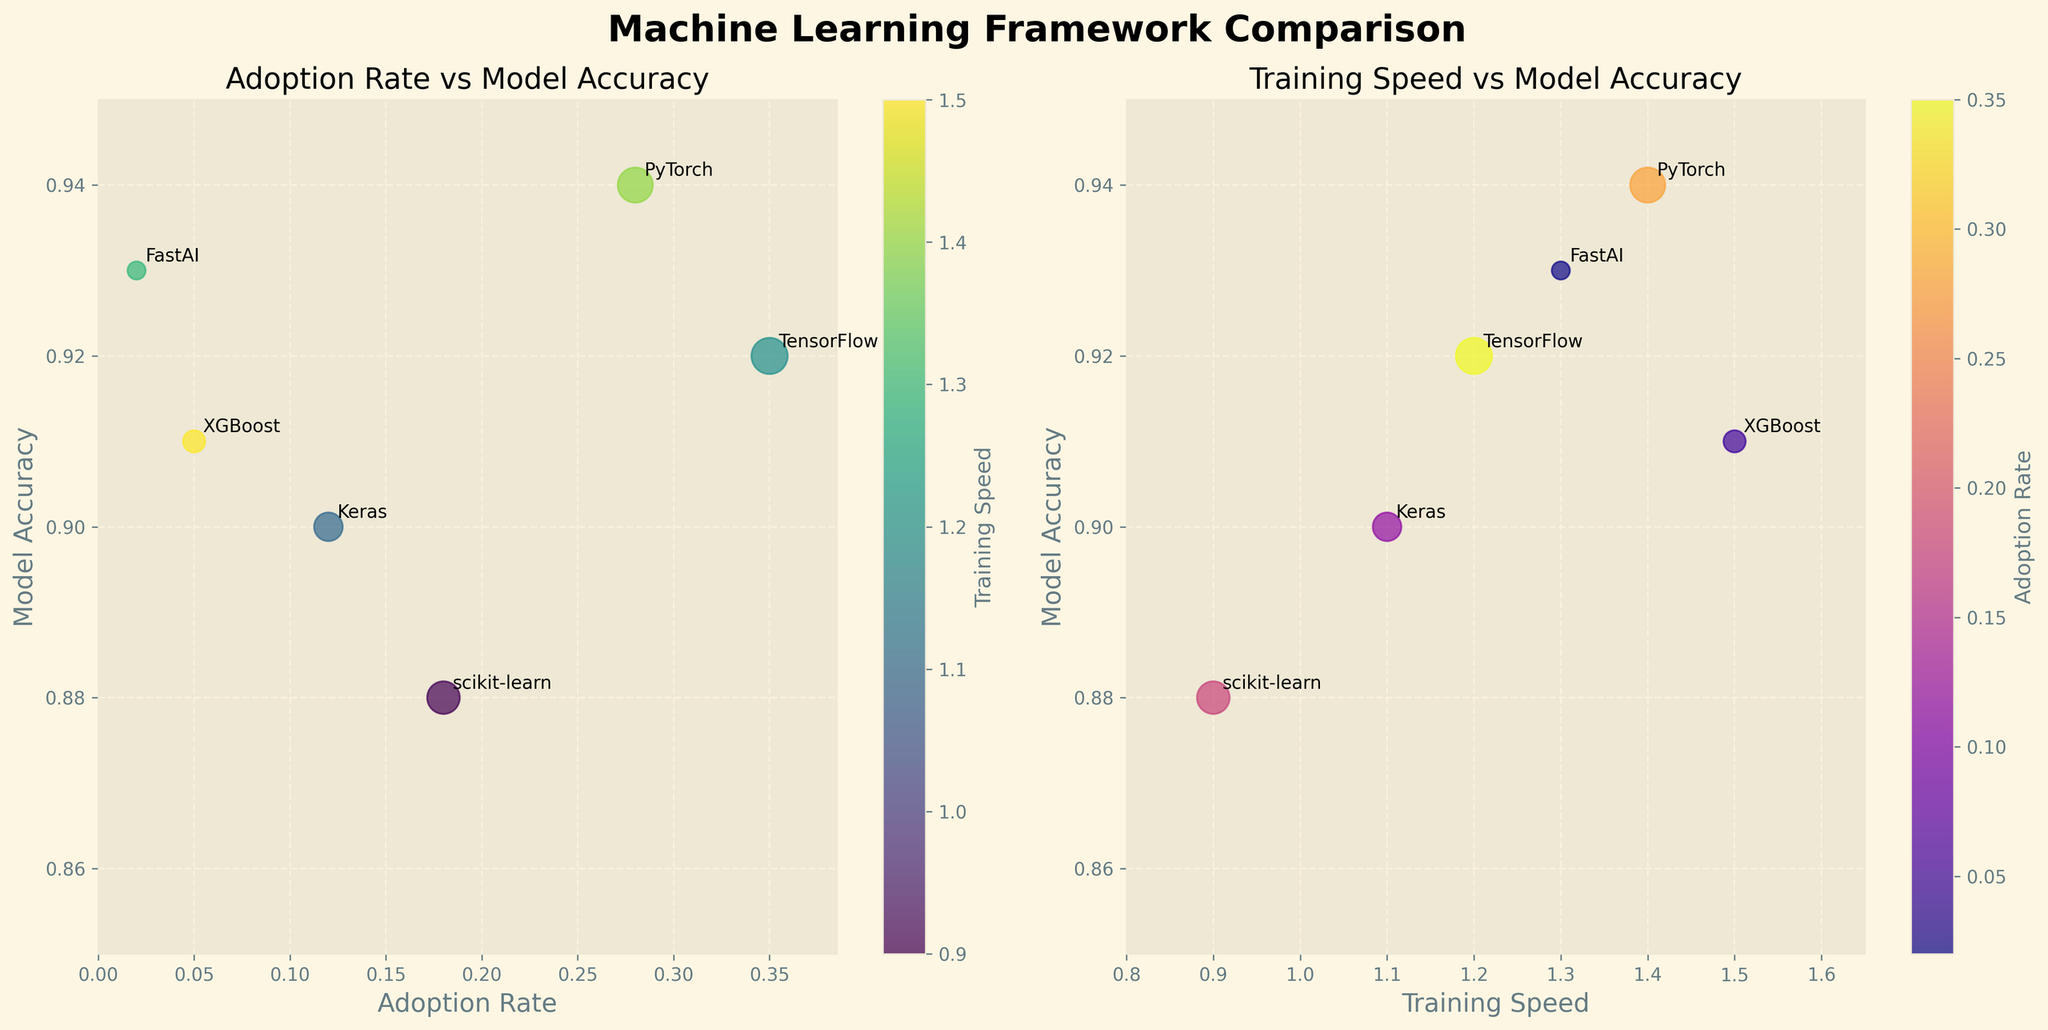Which framework has the highest model accuracy in the subplot? The figure shows different machine learning frameworks, each represented by bubbles. By looking at the vertical axis which represents model accuracy, the framework with the highest point is PyTorch.
Answer: PyTorch What is the range of model accuracy values in the subplot? To determine the range of model accuracy, identify the minimum and maximum values on the vertical axis. The lowest model accuracy is scikit-learn with 0.88, and the highest is PyTorch with 0.94. Therefore, the range is 0.94 - 0.88 = 0.06.
Answer: 0.06 Which framework is the fastest in training speed while maintaining an accuracy above 0.90? From the subplot on Training Speed vs. Model Accuracy, locate the bubbles above the 0.90 mark on the vertical axis. Among these, XGBoost has the highest training speed.
Answer: XGBoost How does the popularity of TensorFlow compare to that of Keras in the subplot? Compare the bubble sizes of TensorFlow and Keras in either subplot. TensorFlow's bubble is much larger than Keras's, indicating higher popularity.
Answer: TensorFlow is more popular than Keras Which frameworks have a model accuracy below 0.90, and what are their adoption rates? Identify the bubbles that fall below the 0.90 mark on the vertical axis in either subplot. scikit-learn (0.18 adoption rate) fits this criterion.
Answer: scikit-learn (0.18 adoption rate) What is the average adoption rate of the frameworks shown in the subplot? To find the average adoption rate, sum all the adoption rates and divide by the number of frameworks: (0.35 + 0.28 + 0.18 + 0.12 + 0.05 + 0.02) / 6. This equals 1.00 / 6 ≈ 0.167.
Answer: 0.167 If you wanted to choose a machine learning framework that balances between training speed and high model accuracy, which one would you choose based on the subplot? Look at the Training Speed vs. Model Accuracy plot. Frameworks like PyTorch and FastAI have high accuracies and reasonable training speeds, but PyTorch is more popular, adding to its utility.
Answer: PyTorch Which framework has the lowest adoption rate, and what is its model accuracy? In the Adoption Rate vs. Model Accuracy subplot, find the smallest adoption rate on the horizontal axis. FastAI has the lowest adoption rate with a model accuracy of 0.93.
Answer: FastAI (0.93 accuracy) Is there any framework with both high adoption rate and high training speed? Look at both subplots for frameworks with high values on both axes. PyTorch has a relatively high adoption rate (0.28) and a high training speed (1.4).
Answer: PyTorch 